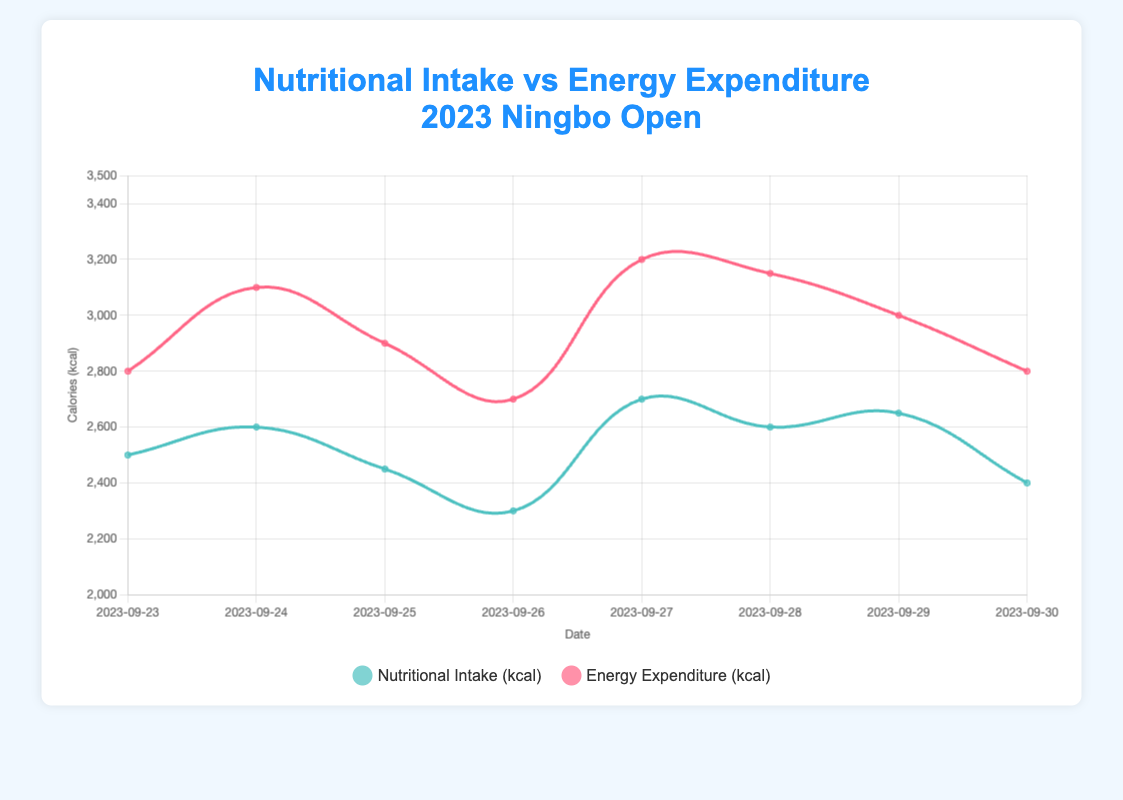What was the energy expenditure in kcal on the day the nutritional intake was highest? The highest nutritional intake is on 2023-09-27 at 2700 kcal. On this day, the energy expenditure is 3200 kcal.
Answer: 3200 kcal Which day showed the greatest difference between nutritional intake and energy expenditure? By calculating the difference for each day: 
2023-09-23: 2800 - 2500 = 300,
2023-09-24: 3100 - 2600 = 500,
2023-09-25: 2900 - 2450 = 450,
2023-09-26: 2700 - 2300 = 400,
2023-09-27: 3200 - 2700 = 500,
2023-09-28: 3150 - 2600 = 550,
2023-09-29: 3000 - 2650 = 350,
2023-09-30: 2800 - 2400 = 400. 
The greatest difference is on 2023-09-28 with 550 kcal.
Answer: 2023-09-28 What was the activity type on the day with the lowest nutritional intake? The day with the lowest nutritional intake is 2023-09-26 at 2300 kcal. The activity type on this day is "Rest Day."
Answer: Rest Day How many days had a higher energy expenditure compared to nutritional intake? Comparing the nutritional intake and energy expenditure for each day: 
2023-09-23: 2800 > 2500,
2023-09-24: 3100 > 2600,
2023-09-25: 2900 > 2450,
2023-09-26: 2700 > 2300,
2023-09-27: 3200 > 2700,
2023-09-28: 3150 > 2600,
2023-09-29: 3000 > 2650,
2023-09-30: 2800 > 2400. 
All 8 days had higher energy expenditure compared to nutritional intake.
Answer: 8 days What is the average nutritional intake over the dataset? Summing all nutritional intake values: 2500 + 2600 + 2450 + 2300 + 2700 + 2600 + 2650 + 2400 = 20200 kcal. Dividing by the number of days, 20200 / 8 = 2525 kcal.
Answer: 2525 kcal On which day did nutritional intake and energy expenditure both show an upward trend compared to the previous day? Reviewing the chart: From 2023-09-25 to 2023-09-26, both nutritional intake decreased (2450 to 2300) and energy expenditure decreased (2900 to 2700). From 2023-09-26 to 2023-09-27, nutritional intake increased (2300 to 2700) and energy expenditure increased (2700 to 3200).
Answer: 2023-09-27 What is the average difference between energy expenditure and nutritional intake over the period? Calculating the difference for each day: 
2023-09-23: 2800 - 2500 = 300, 
2023-09-24: 3100 - 2600 = 500, 
2023-09-25: 2900 - 2450 = 450, 
2023-09-26: 2700 - 2300 = 400, 
2023-09-27: 3200 - 2700 = 500, 
2023-09-28: 3150 - 2600 = 550, 
2023-09-29: 3000 - 2650 = 350, 
2023-09-30: 2800 - 2400 = 400. 
Summing the differences: 300 + 500 + 450 + 400 + 500 + 550 + 350 + 400 = 3450. Average difference = 3450 / 8 = 431.25.
Answer: 431.25 On which days were both nutritional intake and energy expenditure at their highest values for the period? Reviewing the chart: 
Highest nutritional intake: 2700 kcal on 2023-09-27. 
Highest energy expenditure: 3200 kcal on 2023-09-27. Both highest values observed on 2023-09-27.
Answer: 2023-09-27 